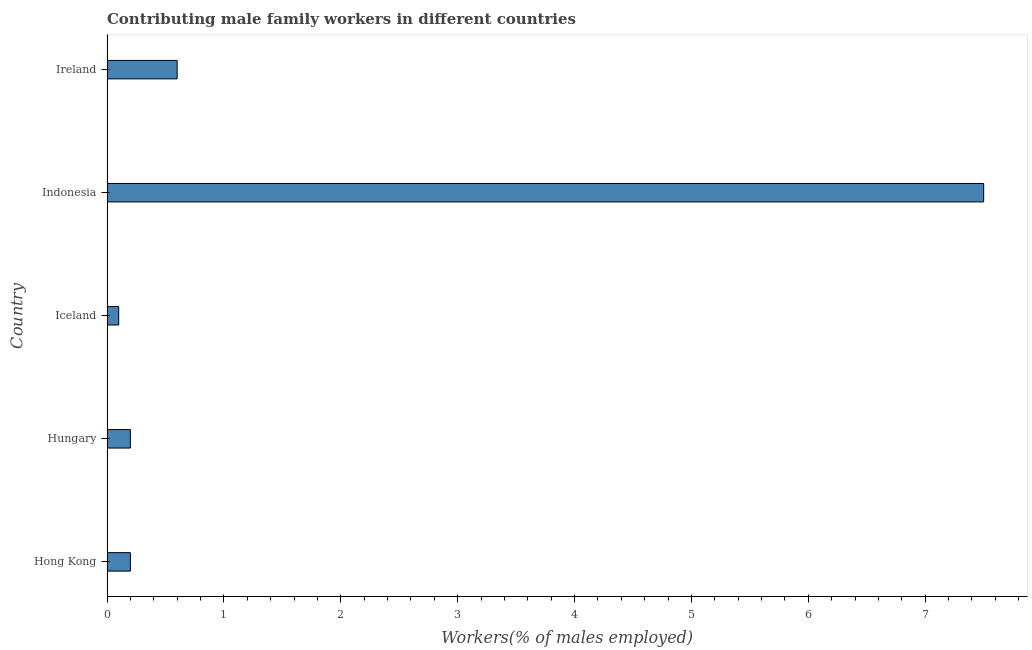What is the title of the graph?
Give a very brief answer. Contributing male family workers in different countries. What is the label or title of the X-axis?
Ensure brevity in your answer.  Workers(% of males employed). What is the label or title of the Y-axis?
Provide a short and direct response. Country. Across all countries, what is the maximum contributing male family workers?
Your answer should be very brief. 7.5. Across all countries, what is the minimum contributing male family workers?
Offer a terse response. 0.1. What is the sum of the contributing male family workers?
Your response must be concise. 8.6. What is the average contributing male family workers per country?
Keep it short and to the point. 1.72. What is the median contributing male family workers?
Offer a terse response. 0.2. In how many countries, is the contributing male family workers greater than 4 %?
Your answer should be very brief. 1. What is the ratio of the contributing male family workers in Hong Kong to that in Indonesia?
Keep it short and to the point. 0.03. Is the contributing male family workers in Iceland less than that in Indonesia?
Offer a terse response. Yes. Is the difference between the contributing male family workers in Iceland and Ireland greater than the difference between any two countries?
Your answer should be compact. No. Are all the bars in the graph horizontal?
Offer a terse response. Yes. What is the difference between two consecutive major ticks on the X-axis?
Make the answer very short. 1. What is the Workers(% of males employed) in Hong Kong?
Offer a terse response. 0.2. What is the Workers(% of males employed) in Hungary?
Your answer should be very brief. 0.2. What is the Workers(% of males employed) of Iceland?
Provide a succinct answer. 0.1. What is the Workers(% of males employed) of Indonesia?
Provide a short and direct response. 7.5. What is the Workers(% of males employed) of Ireland?
Your response must be concise. 0.6. What is the difference between the Workers(% of males employed) in Hong Kong and Hungary?
Make the answer very short. 0. What is the difference between the Workers(% of males employed) in Hong Kong and Iceland?
Provide a succinct answer. 0.1. What is the difference between the Workers(% of males employed) in Hong Kong and Indonesia?
Your response must be concise. -7.3. What is the difference between the Workers(% of males employed) in Hong Kong and Ireland?
Keep it short and to the point. -0.4. What is the difference between the Workers(% of males employed) in Hungary and Indonesia?
Provide a short and direct response. -7.3. What is the difference between the Workers(% of males employed) in Iceland and Indonesia?
Make the answer very short. -7.4. What is the difference between the Workers(% of males employed) in Indonesia and Ireland?
Offer a very short reply. 6.9. What is the ratio of the Workers(% of males employed) in Hong Kong to that in Iceland?
Your answer should be very brief. 2. What is the ratio of the Workers(% of males employed) in Hong Kong to that in Indonesia?
Offer a very short reply. 0.03. What is the ratio of the Workers(% of males employed) in Hong Kong to that in Ireland?
Your response must be concise. 0.33. What is the ratio of the Workers(% of males employed) in Hungary to that in Iceland?
Keep it short and to the point. 2. What is the ratio of the Workers(% of males employed) in Hungary to that in Indonesia?
Offer a very short reply. 0.03. What is the ratio of the Workers(% of males employed) in Hungary to that in Ireland?
Offer a very short reply. 0.33. What is the ratio of the Workers(% of males employed) in Iceland to that in Indonesia?
Your answer should be very brief. 0.01. What is the ratio of the Workers(% of males employed) in Iceland to that in Ireland?
Your answer should be very brief. 0.17. What is the ratio of the Workers(% of males employed) in Indonesia to that in Ireland?
Make the answer very short. 12.5. 